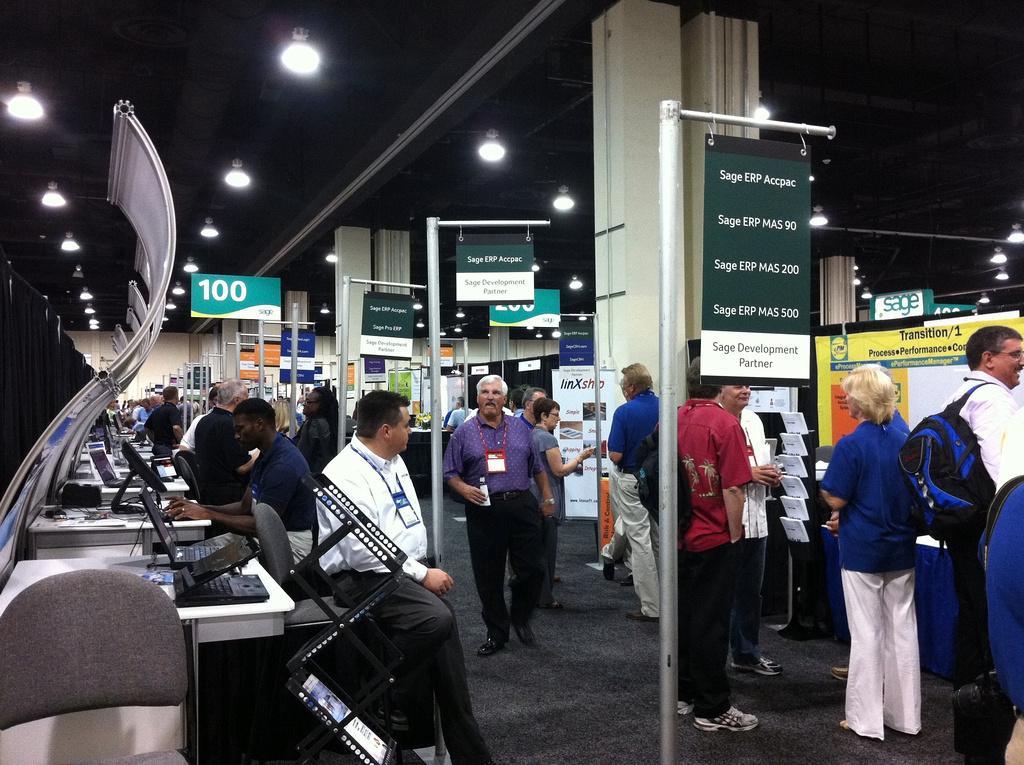Can you describe this image briefly? On the left there are few people sitting on the chair and working on the computer. On the right there are few people,hoardings,poles,banners. On the rooftop there are lights. 